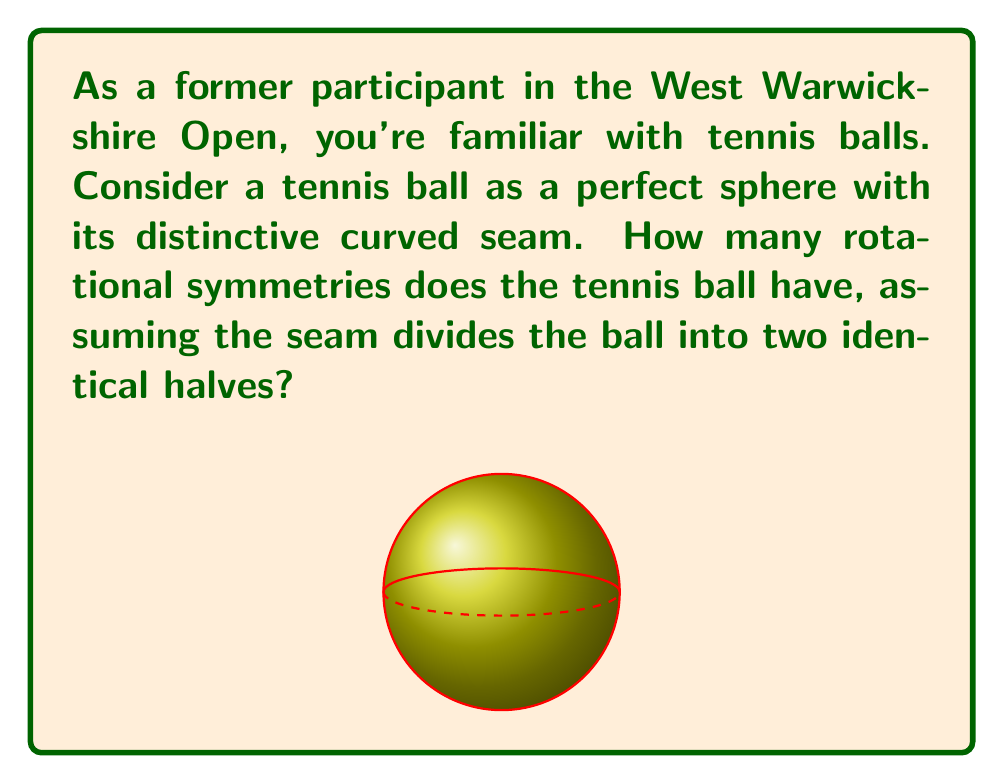Solve this math problem. Let's approach this step-by-step:

1) First, we need to understand what rotational symmetries mean for a tennis ball. A rotational symmetry exists if we can rotate the ball and it looks the same as before.

2) The tennis ball has two key features:
   a) It's a sphere
   b) It has a seam that divides it into two identical halves

3) For a perfect sphere without any markings, there would be infinite rotational symmetries. However, the seam limits these symmetries.

4) The seam creates two types of rotational symmetries:
   a) Rotations around the axis perpendicular to the seam plane
   b) 180° rotations around any diameter in the seam plane

5) For type (a), we can rotate the ball by any angle around this axis, giving us infinite symmetries. Mathematically, this is represented by the group $SO(2)$.

6) For type (b), there are infinite diameters in the seam plane, each allowing a 180° rotation. This gives us another set of infinite symmetries.

7) The combination of these two types of rotations forms the orthogonal group $O(3)$, which represents all possible rotations and reflections in 3D space.

8) However, since we're only considering rotations (not reflections), we're dealing with the special orthogonal group $SO(3)$.

Therefore, the rotation group for a tennis ball is $SO(3)$, which has an infinite order.
Answer: $\infty$ (infinite) 